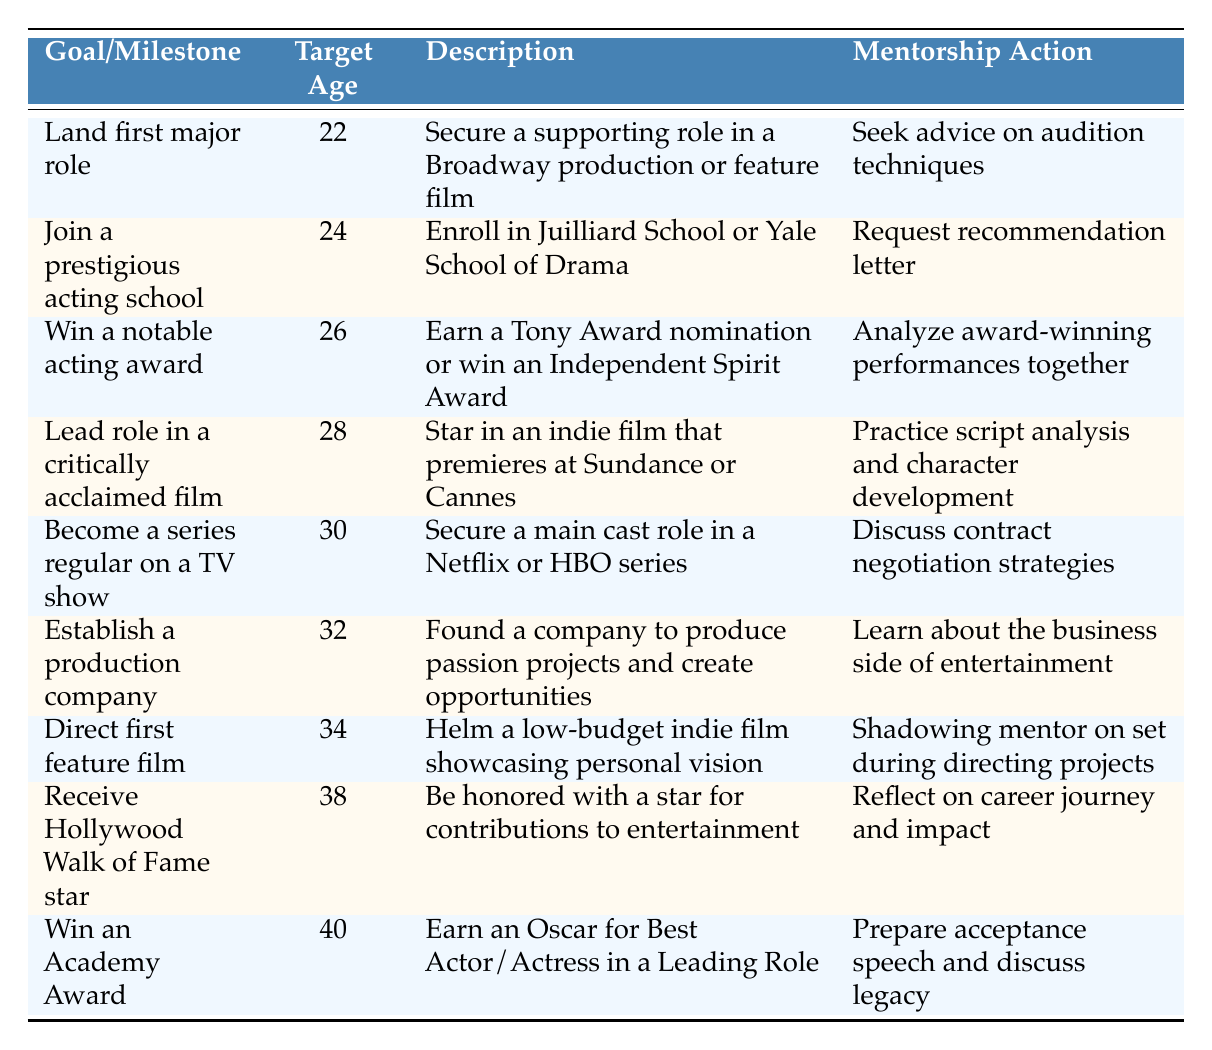What is the target age for landing the first major role? The table indicates that the target age for landing the first major role is 22. This information can be directly found in the "Target Age" column corresponding to the row detailing the goal of landing the first major role.
Answer: 22 How many years do you have to wait after joining a prestigious acting school to win a notable acting award? According to the table, the target age for joining a prestigious acting school is 24, and winning a notable acting award has a target age of 26. The difference is 26 - 24 = 2 years.
Answer: 2 years Is it true that directing the first feature film occurs before establishing a production company? By examining the "Target Age" column, directing the first feature film has a target age of 34, whereas establishing a production company is set at 32. Since 34 is greater than 32, the statement is false.
Answer: No What is the mentorship action associated with winning an Academy Award? The table lists the mentorship action for winning an Academy Award as "Prepare acceptance speech and discuss legacy." This can be directly referenced in the row corresponding to the Academy Award in the "Mentorship Action" column.
Answer: Prepare acceptance speech and discuss legacy What are the target ages for becoming a series regular on a TV show and receiving a Hollywood Walk of Fame star? The table states the target age for becoming a series regular on a TV show is 30 and for receiving a Hollywood Walk of Fame star is 38. Thus, the years can be listed together as (30, 38).
Answer: (30, 38) How many people need to achieve the milestone of winning an Academy Award after receiving a Hollywood Walk of Fame star? From the table, the target age for receiving a Hollywood Walk of Fame star is 38 and for winning an Academy Award is 40. Therefore, it's necessary to collect these milestones in sequential order, indicating 1 year after the Walk of Fame star.
Answer: 1 year Which goal has the earliest target age, and what is that age? By reviewing the "Target Age" column, we find that the goal with the earliest target age is "Land first major role," which is set at 22. This can be identified as the minimal value in the target age entries provided.
Answer: 22 What do you learn about the progression from establishing a production company to directing the first feature film? The table details that establishing a production company has a target age of 32 and directing the first feature film occurs at age 34. Thus, the stage of establishing a production company occurs before directing the first feature film, with an interval of 2 years between them.
Answer: 2 years 